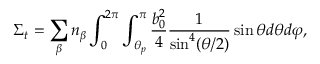<formula> <loc_0><loc_0><loc_500><loc_500>{ \Sigma } _ { t } = \sum _ { \beta } { { { n } _ { \beta } } \int _ { 0 } ^ { 2 \pi } { \int _ { { { \theta } _ { p } } } ^ { \pi } { \frac { b _ { 0 } ^ { 2 } } { 4 } \frac { 1 } { { { \sin } ^ { 4 } } ( \theta / 2 ) } \sin \theta d \theta d \varphi } } } ,</formula> 